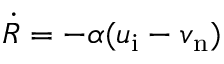Convert formula to latex. <formula><loc_0><loc_0><loc_500><loc_500>\dot { R } = - \alpha ( u _ { i } - v _ { n } )</formula> 